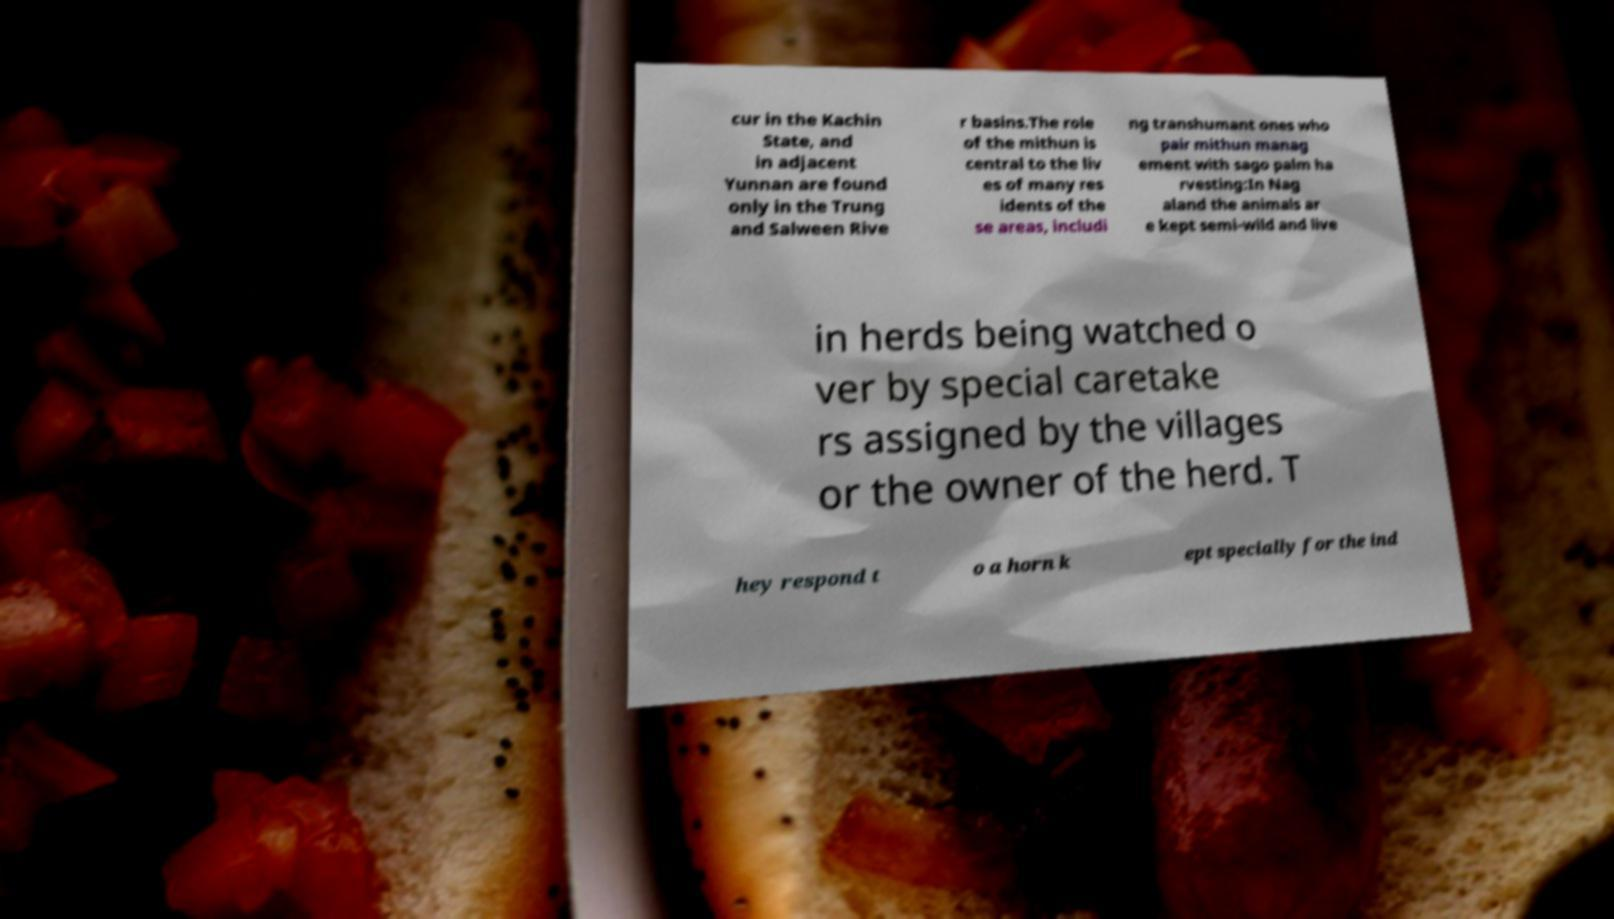Could you assist in decoding the text presented in this image and type it out clearly? cur in the Kachin State, and in adjacent Yunnan are found only in the Trung and Salween Rive r basins.The role of the mithun is central to the liv es of many res idents of the se areas, includi ng transhumant ones who pair mithun manag ement with sago palm ha rvesting:In Nag aland the animals ar e kept semi-wild and live in herds being watched o ver by special caretake rs assigned by the villages or the owner of the herd. T hey respond t o a horn k ept specially for the ind 